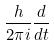Convert formula to latex. <formula><loc_0><loc_0><loc_500><loc_500>\frac { h } { 2 \pi i } \frac { d } { d t }</formula> 